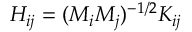Convert formula to latex. <formula><loc_0><loc_0><loc_500><loc_500>H _ { i j } = ( M _ { i } M _ { j } ) ^ { - 1 / 2 } K _ { i j }</formula> 